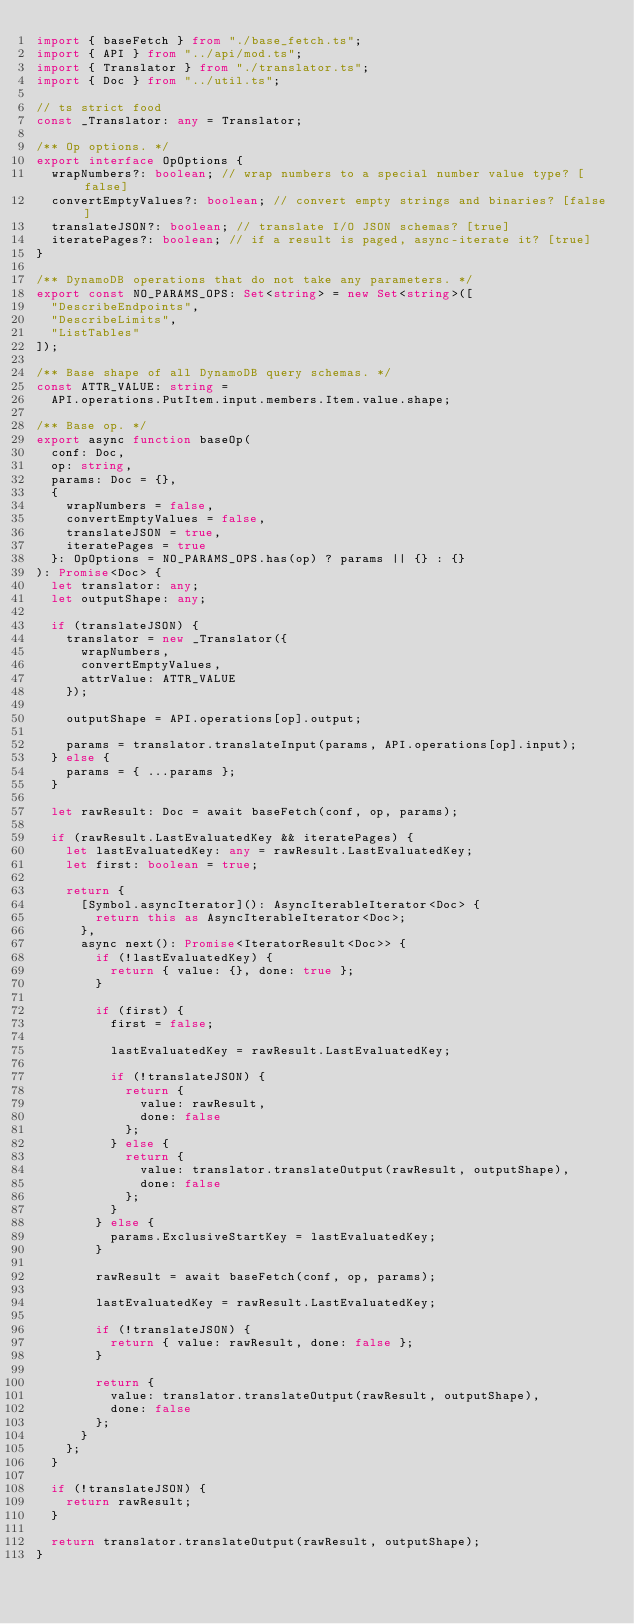<code> <loc_0><loc_0><loc_500><loc_500><_TypeScript_>import { baseFetch } from "./base_fetch.ts";
import { API } from "../api/mod.ts";
import { Translator } from "./translator.ts";
import { Doc } from "../util.ts";

// ts strict food
const _Translator: any = Translator;

/** Op options. */
export interface OpOptions {
  wrapNumbers?: boolean; // wrap numbers to a special number value type? [false]
  convertEmptyValues?: boolean; // convert empty strings and binaries? [false]
  translateJSON?: boolean; // translate I/O JSON schemas? [true]
  iteratePages?: boolean; // if a result is paged, async-iterate it? [true]
}

/** DynamoDB operations that do not take any parameters. */
export const NO_PARAMS_OPS: Set<string> = new Set<string>([
  "DescribeEndpoints",
  "DescribeLimits",
  "ListTables"
]);

/** Base shape of all DynamoDB query schemas. */
const ATTR_VALUE: string =
  API.operations.PutItem.input.members.Item.value.shape;

/** Base op. */
export async function baseOp(
  conf: Doc,
  op: string,
  params: Doc = {},
  {
    wrapNumbers = false,
    convertEmptyValues = false,
    translateJSON = true,
    iteratePages = true
  }: OpOptions = NO_PARAMS_OPS.has(op) ? params || {} : {}
): Promise<Doc> {
  let translator: any;
  let outputShape: any;

  if (translateJSON) {
    translator = new _Translator({
      wrapNumbers,
      convertEmptyValues,
      attrValue: ATTR_VALUE
    });

    outputShape = API.operations[op].output;

    params = translator.translateInput(params, API.operations[op].input);
  } else {
    params = { ...params };
  }

  let rawResult: Doc = await baseFetch(conf, op, params);

  if (rawResult.LastEvaluatedKey && iteratePages) {
    let lastEvaluatedKey: any = rawResult.LastEvaluatedKey;
    let first: boolean = true;

    return {
      [Symbol.asyncIterator](): AsyncIterableIterator<Doc> {
        return this as AsyncIterableIterator<Doc>;
      },
      async next(): Promise<IteratorResult<Doc>> {
        if (!lastEvaluatedKey) {
          return { value: {}, done: true };
        }

        if (first) {
          first = false;

          lastEvaluatedKey = rawResult.LastEvaluatedKey;

          if (!translateJSON) {
            return {
              value: rawResult,
              done: false
            };
          } else {
            return {
              value: translator.translateOutput(rawResult, outputShape),
              done: false
            };
          }
        } else {
          params.ExclusiveStartKey = lastEvaluatedKey;
        }

        rawResult = await baseFetch(conf, op, params);

        lastEvaluatedKey = rawResult.LastEvaluatedKey;

        if (!translateJSON) {
          return { value: rawResult, done: false };
        }

        return {
          value: translator.translateOutput(rawResult, outputShape),
          done: false
        };
      }
    };
  }

  if (!translateJSON) {
    return rawResult;
  }

  return translator.translateOutput(rawResult, outputShape);
}
</code> 